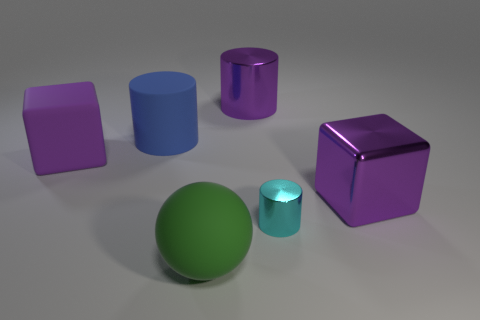Is there any other thing that has the same size as the cyan metal thing?
Your answer should be compact. No. What number of cyan things are large spheres or metal things?
Offer a terse response. 1. There is a big blue thing that is the same shape as the cyan shiny thing; what is its material?
Provide a short and direct response. Rubber. What shape is the purple thing that is on the left side of the green rubber object?
Provide a short and direct response. Cube. Is there a small blue block made of the same material as the large purple cylinder?
Provide a succinct answer. No. Do the green ball and the purple cylinder have the same size?
Give a very brief answer. Yes. How many cylinders are purple things or large blue things?
Your answer should be very brief. 2. There is a big cylinder that is the same color as the big metallic block; what material is it?
Your response must be concise. Metal. How many cyan things are the same shape as the big blue matte thing?
Ensure brevity in your answer.  1. Are there more big purple shiny things to the right of the small cylinder than big balls that are in front of the big purple shiny block?
Provide a succinct answer. No. 